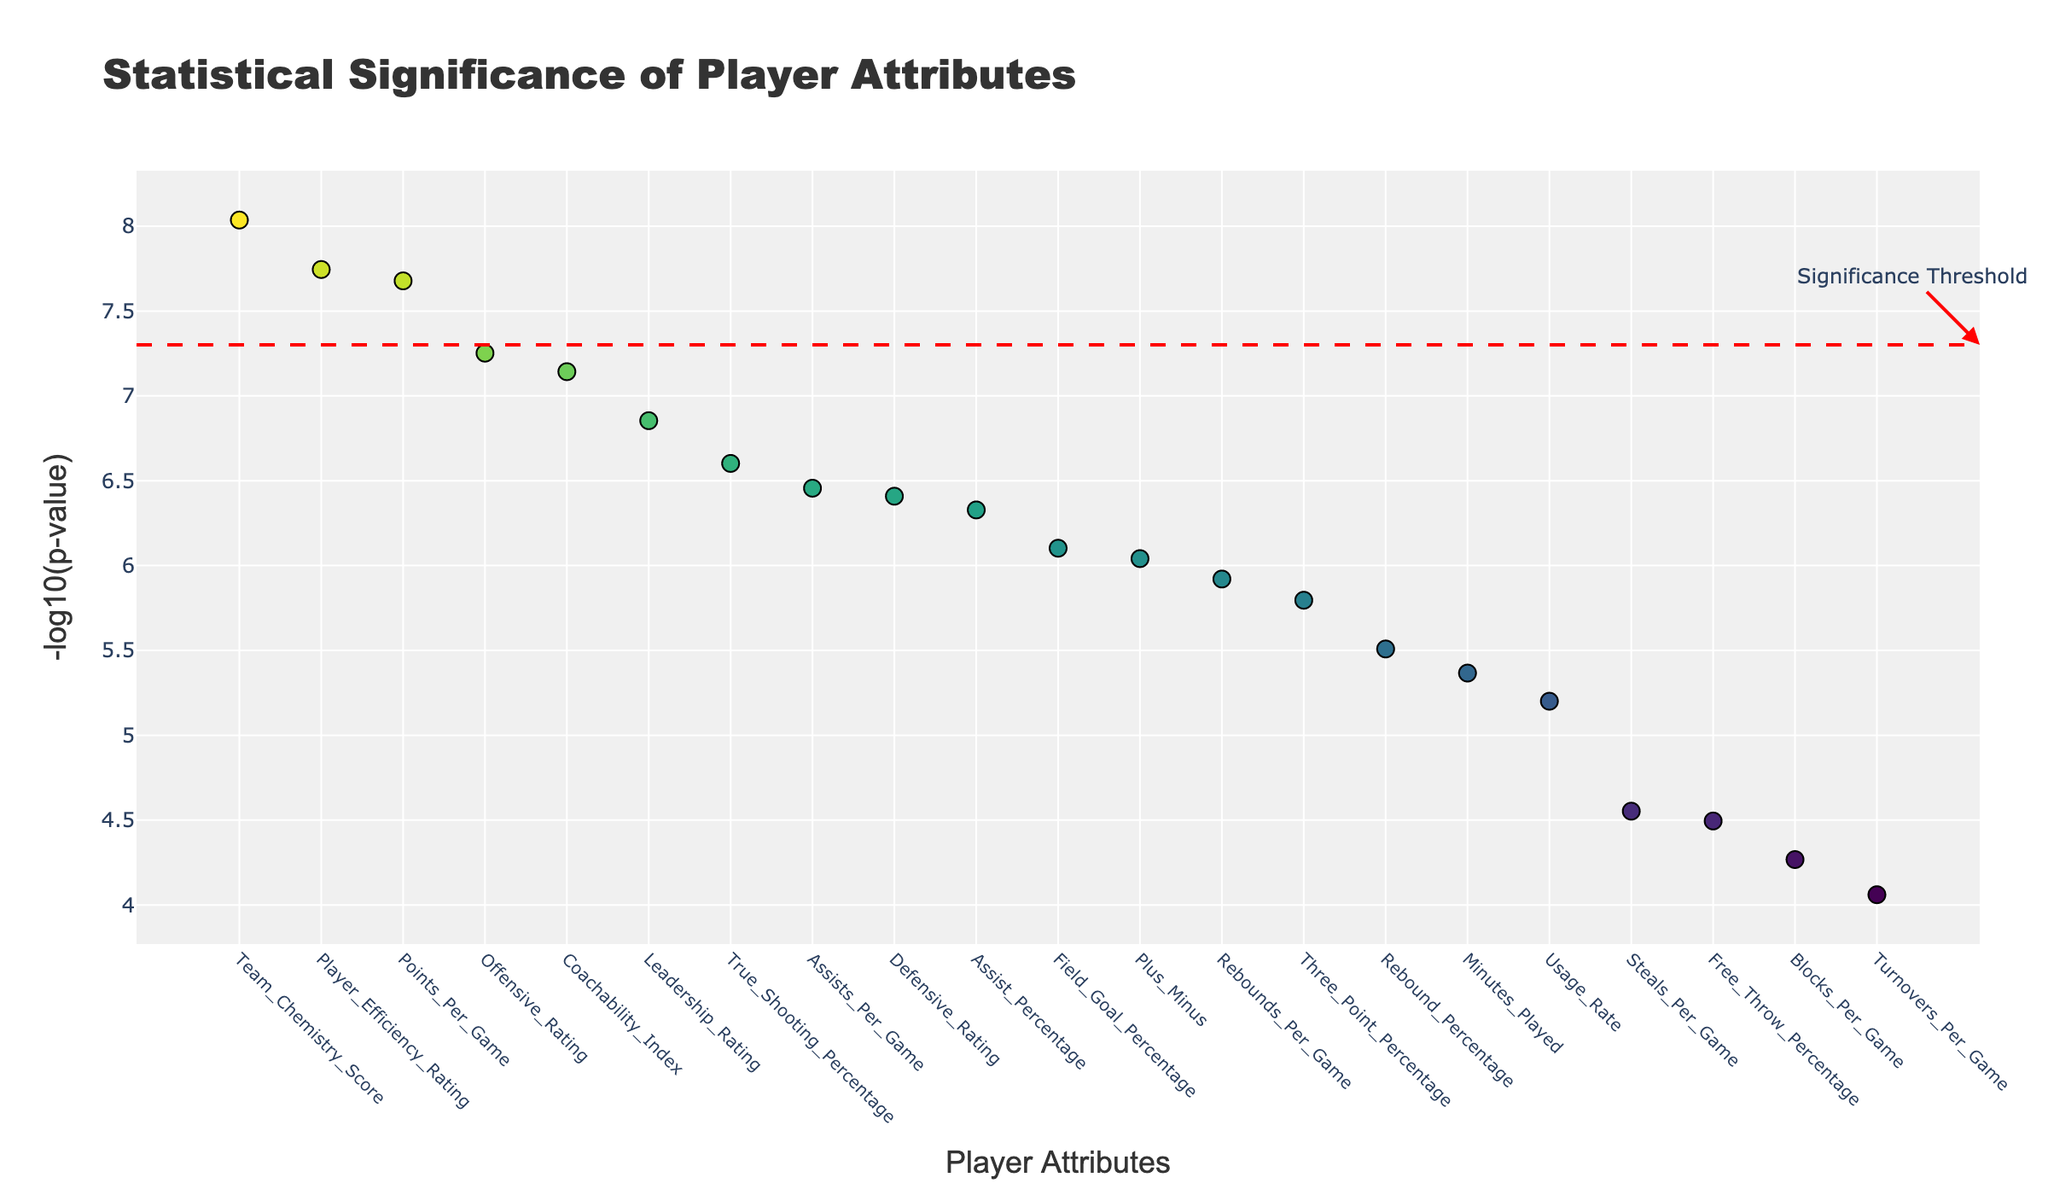What is the title of the plot? The title is located at the top center of the plot. It is in bold and describes the main content or purpose of the plot.
Answer: Statistical Significance of Player Attributes Which attribute has the lowest p-value? The attribute with the highest -log10(p-value) on the y-axis corresponds to the lowest p-value because lower p-values are represented by higher values in this plot.
Answer: Points_Per_Game How many attributes have a -log10(p-value) greater than 7? To find how many attributes meet this criterion, look at the y-axis values and count the number of points above the 7 mark.
Answer: 6 What does the red dashed horizontal line represent? The red dashed line is annotated and typically used in a Manhattan plot to represent a significance threshold, indicating the -log10(p-value) level below which results are considered statistically significant.
Answer: Significance Threshold Which attribute is just above the significance threshold line? By identifying the horizontal significance line and looking for the first point above it, we can find the attribute name.
Answer: Coachability_Index How does the statistical significance of Field_Goal_Percentage compare to Three_Point_Percentage? Compare the -log10(p-value) of Field_Goal_Percentage and Three_Point_Percentage by checking their respective y-axis positions.
Answer: Field_Goal_Percentage is more significant Which two attributes are closest in terms of their statistical significance values? Look for points on the y-axis that are very close to each other in height and compare their x-axis labels.
Answer: Steals_Per_Game and Free_Throw_Percentage What is the significance value of Team_Chemistry_Score? Locate the Team_Chemistry_Score point on the plot and note its y-axis value.
Answer: 8.04 Between Rebounds_Per_Game and Assists_Per_Game, which one is more significant? Compare the -log10(p-value) of Rebounds_Per_Game and Assists_Per_Game from their positions on the y-axis.
Answer: Assists_Per_Game List the attributes with a -log10(p-value) between 6 and 7? Identify all points between the 6 and 7 marks on the y-axis and note their corresponding x-axis labels.
Answer: Defensive_Rating, Usage_Rate, Rebound_Percentage 